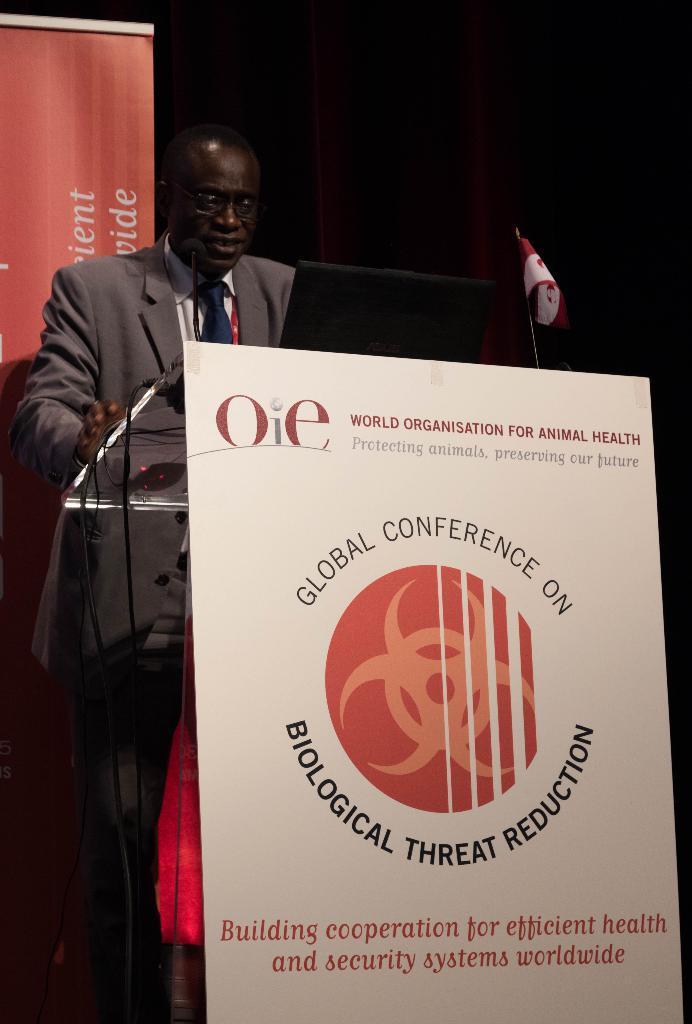Could you give a brief overview of what you see in this image? In the image we can see a poster, podium, cable wire, flag and microphone. There is a man wearing clothes, tie and spectacles. This is a text. 